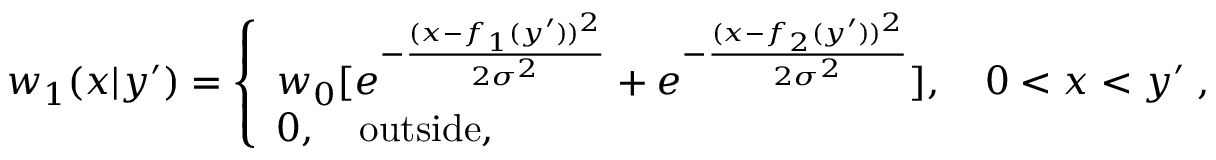<formula> <loc_0><loc_0><loc_500><loc_500>w _ { 1 } ( x | y ^ { \prime } ) = \left \{ \begin{array} { l } { { w _ { 0 } } [ e ^ { - { \frac { ( x - f _ { 1 } ( y ^ { \prime } ) ) ^ { 2 } } { 2 \sigma ^ { 2 } } } } + e ^ { - { \frac { ( x - f _ { 2 } ( y ^ { \prime } ) ) ^ { 2 } } { 2 \sigma ^ { 2 } } } } ] , \quad 0 < x < y ^ { \prime } \, , } \\ { 0 , \quad o u t s i d e , } \end{array}</formula> 